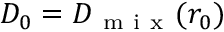<formula> <loc_0><loc_0><loc_500><loc_500>D _ { 0 } = D _ { m i x } ( r _ { 0 } )</formula> 